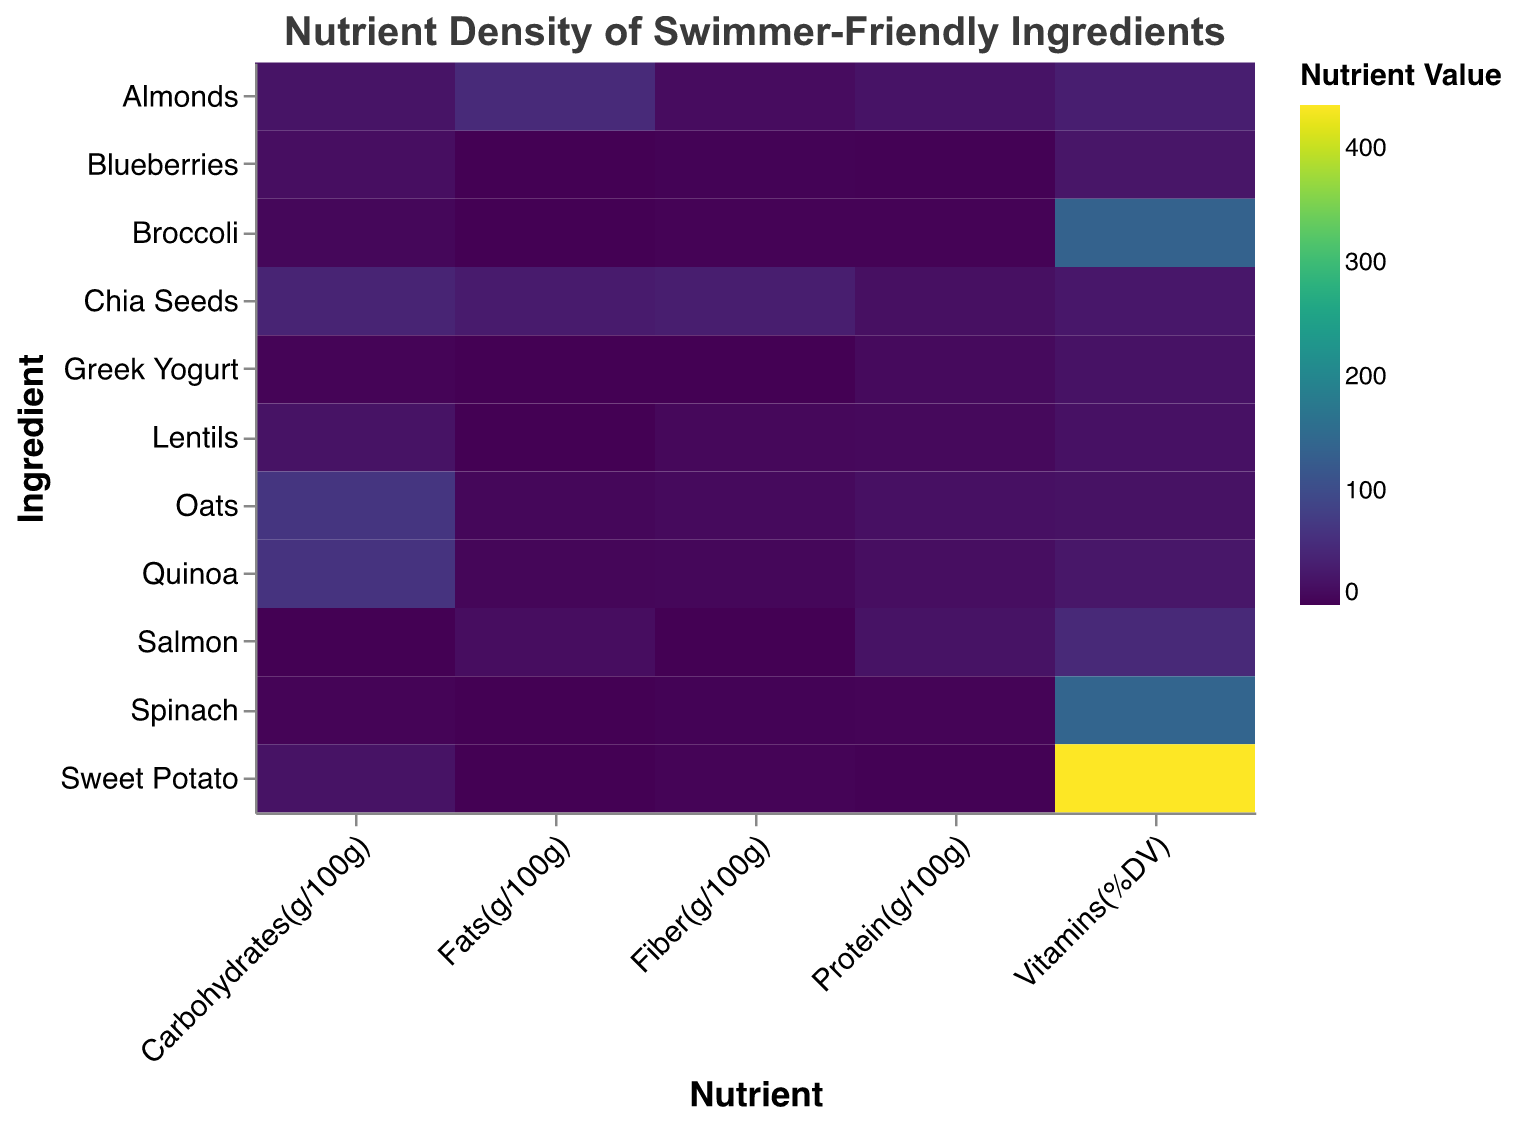Which ingredient has the highest value for protein? The heatmap shows the nutrient density values for various ingredients, and we need to identify the highest value under the "Protein(g/100g)" column. Upon examining, Almonds have the highest protein value.
Answer: Almonds Which ingredient offers the most carbohydrates? To find the ingredient with the highest carbohydrate value, we look at the "Carbohydrates(g/100g)" column in the heatmap. Oats have the highest carbohydrate content.
Answer: Oats What is the range of fiber values for Chia Seeds? To determine the range, we take the highest fiber value for Chia Seeds and subtract the lowest fiber value. Chia Seeds only have one fiber value, which is 34.4g/100g. Therefore, the range is 0.
Answer: 34.4 Which ingredient is highest in vitamins? To find this, we check the "Vitamins(%DV)" column and identify the highest value. Sweet Potato has the highest vitamin value.
Answer: Sweet Potato Which ingredient has the least amount of fats? We need to find the lowest value in the "Fats(g/100g)" column. Several ingredients including Sweet Potato, Blueberries, Greek Yogurt, and Lentils have very low fat values, each with 0.1 or 0.3g. The lowest among these is 0.1g for Sweet Potato.
Answer: Sweet Potato What is the average fiber content across all ingredients? We calculate the average by summing all fiber values and dividing by the number of ingredients. The total fiber is 82.7g, and with 11 ingredients, the average is 82.7/11.
Answer: 7.52g Which ingredient has the highest amount of fats and how much is it? By examining the "Fats(g/100g)" column, we identify Almonds as having the highest fat value.
Answer: Almonds, 50.6g Compare the protein content between Salmon and Greek Yogurt. Which has more protein? Look at the "Protein(g/100g)" values for both Salmon and Greek Yogurt. Salmon has 20.5g, while Greek Yogurt has 10.0g. Therefore, Salmon has more protein.
Answer: Salmon, 20.5g 